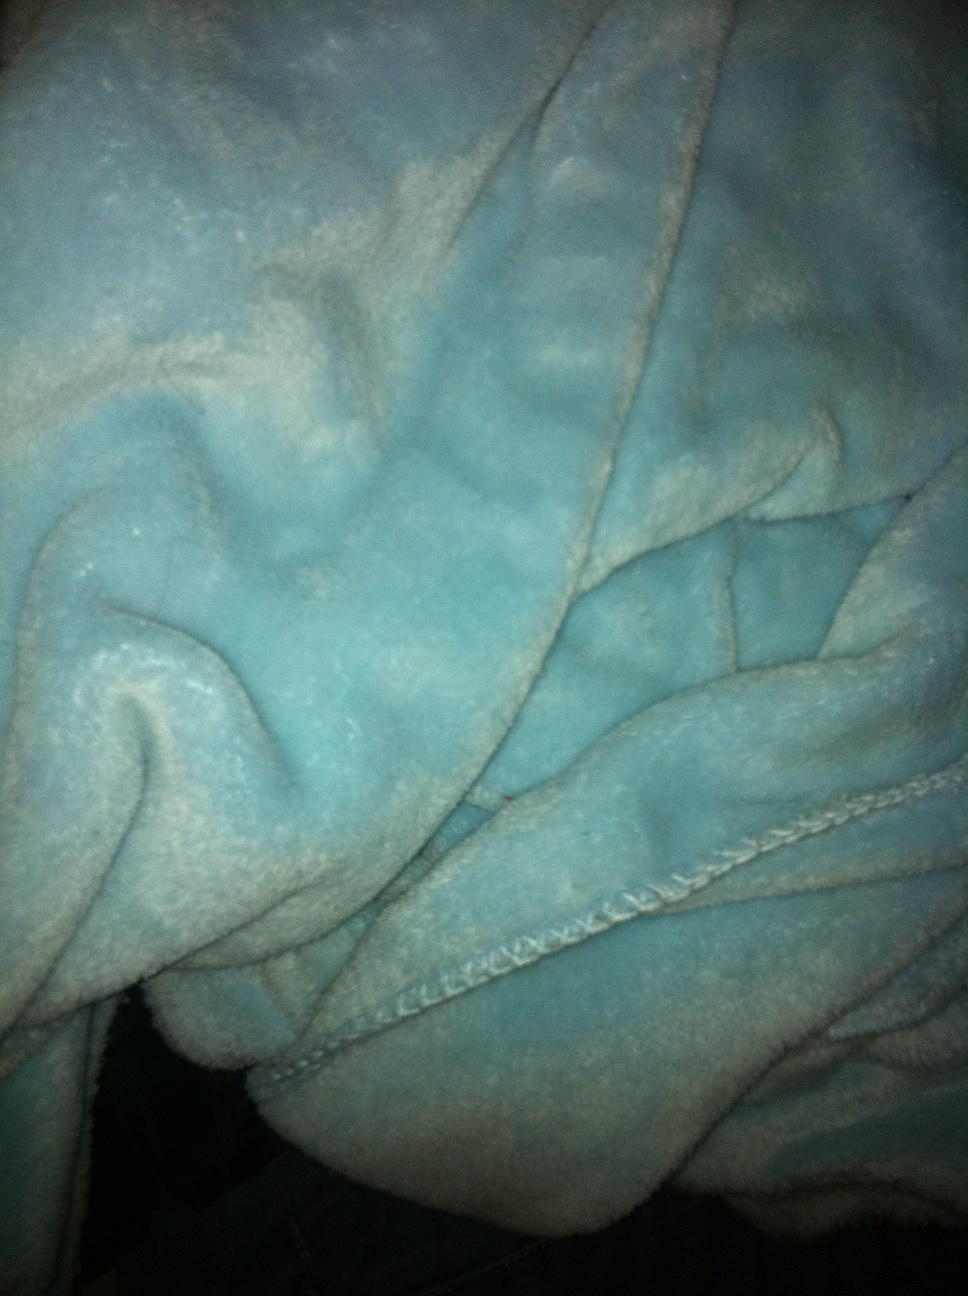What color is this bath robe? The bathrobe in the image appears to be of a soft teal color, which can sometimes be described as a greenish-blue. It looks cozy and plush, ideal for comfort after a bath. 